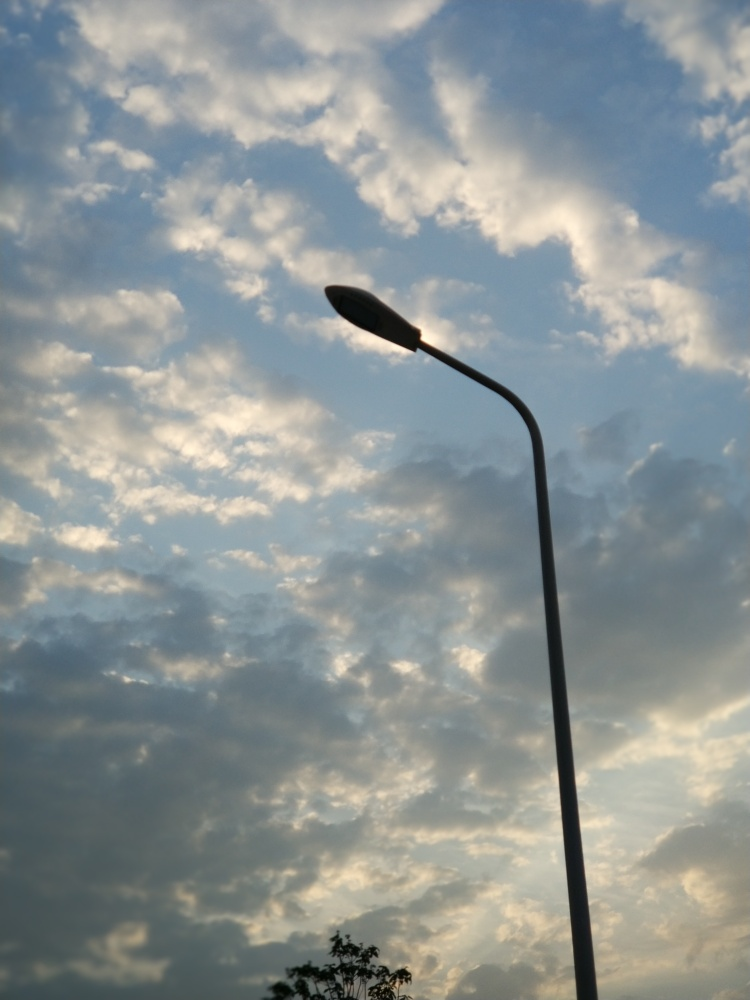Describe the mood or emotion that this image evokes. The image evokes a sense of calm and tranquility, with the peaceful expanse of the sky and gentle formations of clouds. There's a poetic contrast between the natural beauty of the sky and the solitary man-made street lamp, which could also symbolize solitude or quiet contemplation. 